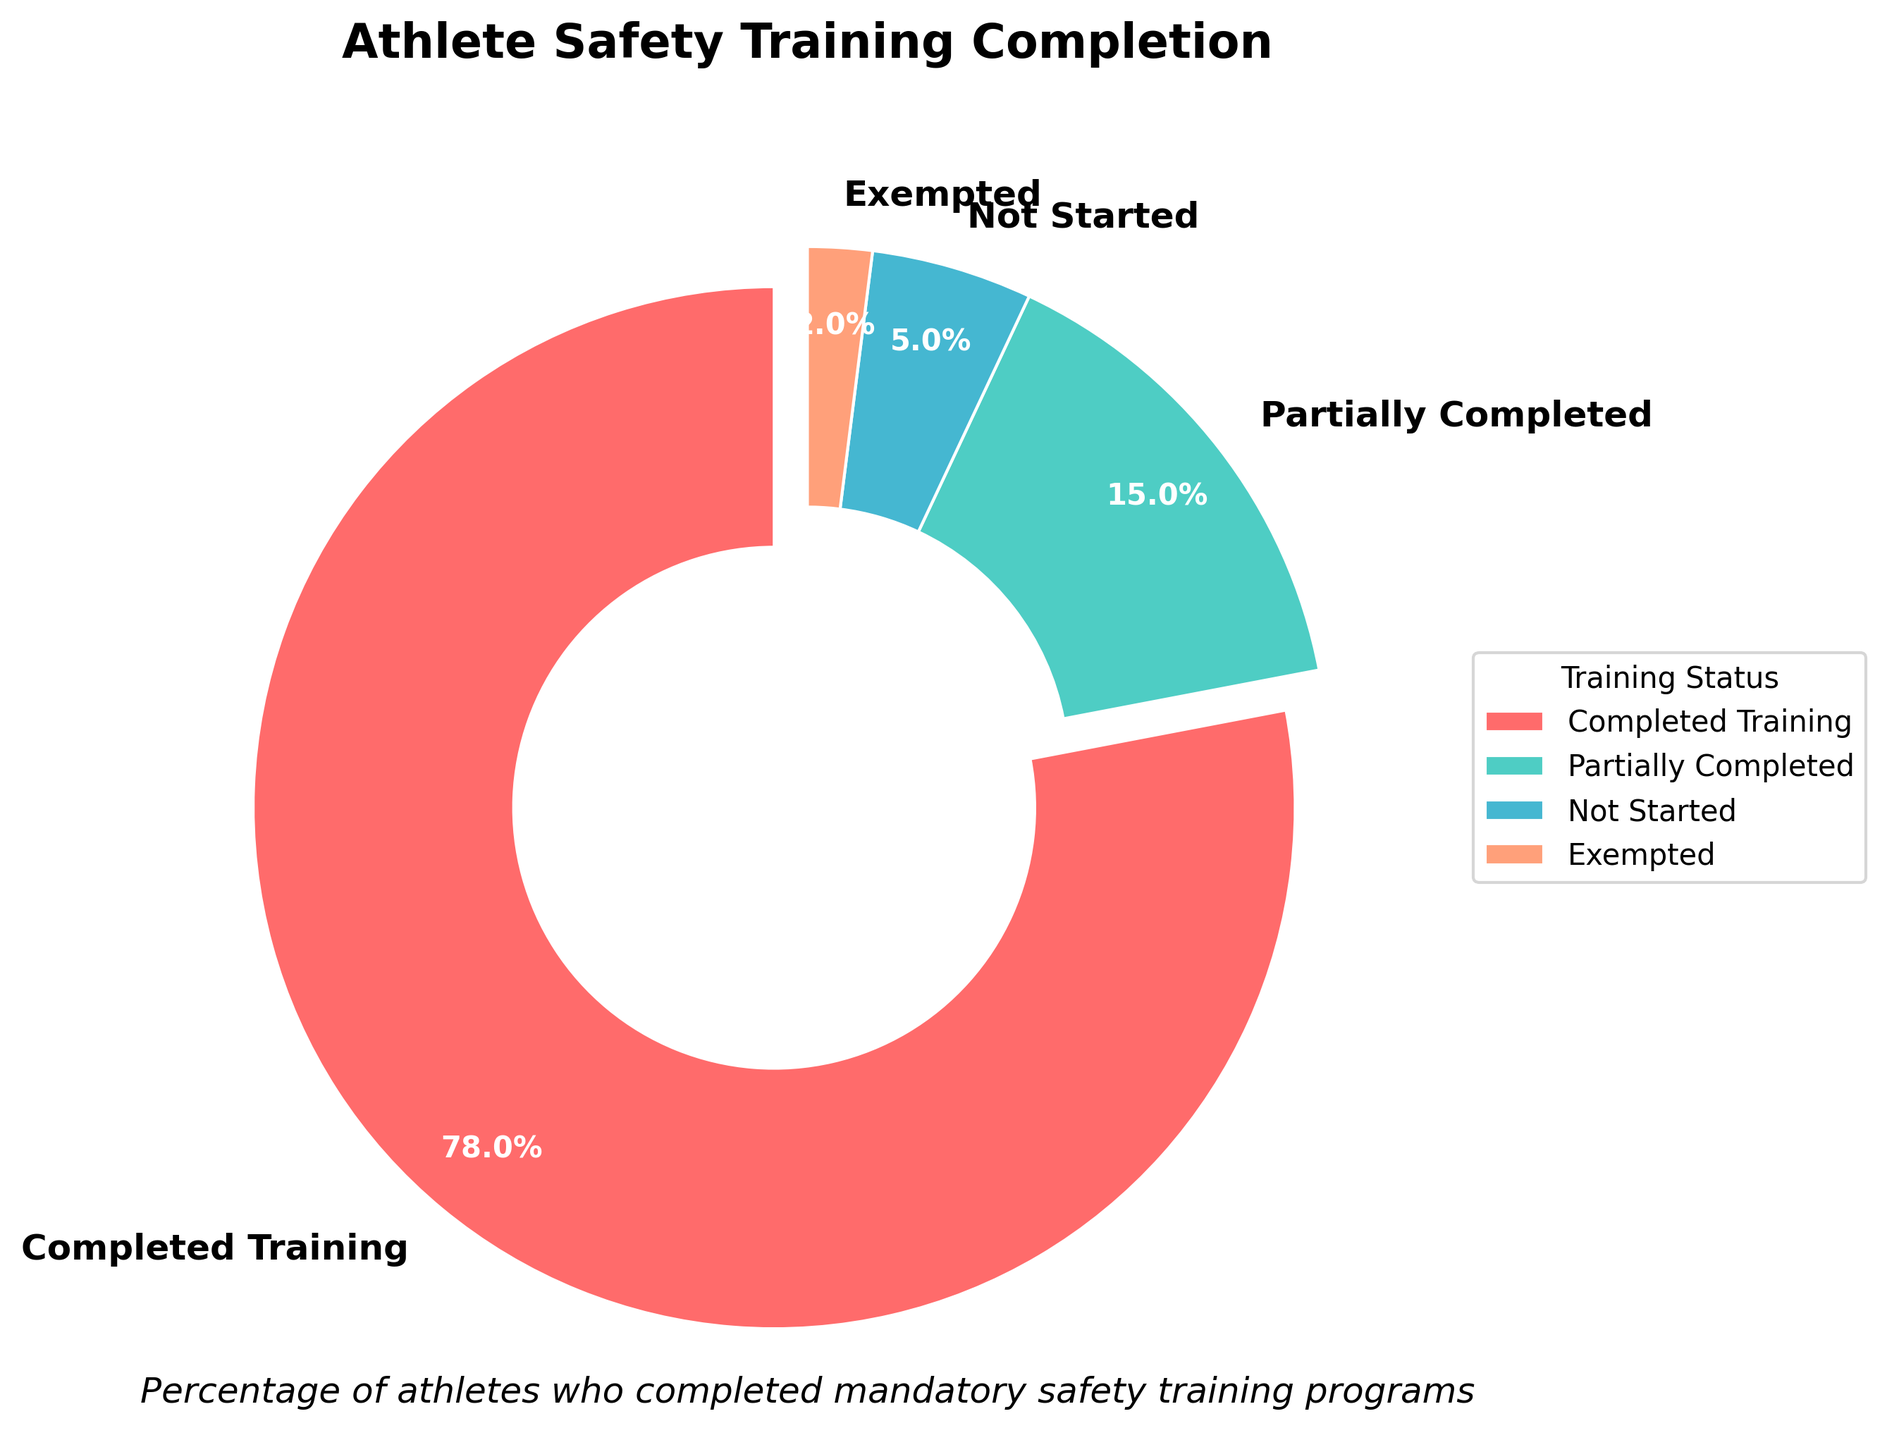What percentage of athletes completed the mandatory safety training? Look at the chart segment labeled "Completed Training" and identify its percentage value.
Answer: 78% What fraction of athletes have either partially completed or not started the training? Identify the percentage values for "Partially Completed" and "Not Started," then sum them up: 15% + 5%.
Answer: 20% Which training status has the smallest percentage of athletes? Identify the segment with the smallest percentage. The label that corresponds to the smallest section is "Exempted" with 2%.
Answer: Exempted What is the difference in percentage between athletes who partially completed the training and those who completed it? Subtract the percentage of the "Partially Completed" segment from the "Completed Training" segment: 78% - 15%
Answer: 63% How many categories have a percentage value greater than 10%? Check each segment's percentage value and count the ones greater than 10%. "Completed Training" and "Partially Completed" fit this criterion.
Answer: 2 Is the percentage of athletes who have not started the training greater than those who are exempted? Compare the segments for "Not Started" and "Exempted." "Not Started" is 5%, and "Exempted" is 2%, so 5% is greater.
Answer: Yes What is the combined percentage for athletes who either have not started or are exempted from the training? Add the percentage values for "Not Started" and "Exempted": 5% + 2%.
Answer: 7% How does the percentage of athletes who completed the training compare to the sum of all other categories? Sum up the percentages of "Partially Completed," "Not Started," and "Exempted" and compare it to the "Completed Training" percentage: 15% + 5% + 2% = 22%, which is less than 78%.
Answer: Completed Training is greater What color represents the athletes who have completed the training? Look at the corresponding segment color for "Completed Training" in the pie chart, which is #FF6B6B (red).
Answer: Red 